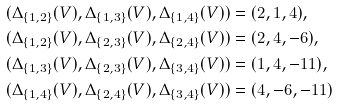Convert formula to latex. <formula><loc_0><loc_0><loc_500><loc_500>& ( \Delta _ { \{ 1 , 2 \} } ( V ) , \Delta _ { \{ 1 , 3 \} } ( V ) , \Delta _ { \{ 1 , 4 \} } ( V ) ) = ( 2 , 1 , 4 ) , \\ & ( \Delta _ { \{ 1 , 2 \} } ( V ) , \Delta _ { \{ 2 , 3 \} } ( V ) , \Delta _ { \{ 2 , 4 \} } ( V ) ) = ( 2 , 4 , - 6 ) , \\ & ( \Delta _ { \{ 1 , 3 \} } ( V ) , \Delta _ { \{ 2 , 3 \} } ( V ) , \Delta _ { \{ 3 , 4 \} } ( V ) ) = ( 1 , 4 , - 1 1 ) , \\ & ( \Delta _ { \{ 1 , 4 \} } ( V ) , \Delta _ { \{ 2 , 4 \} } ( V ) , \Delta _ { \{ 3 , 4 \} } ( V ) ) = ( 4 , - 6 , - 1 1 )</formula> 